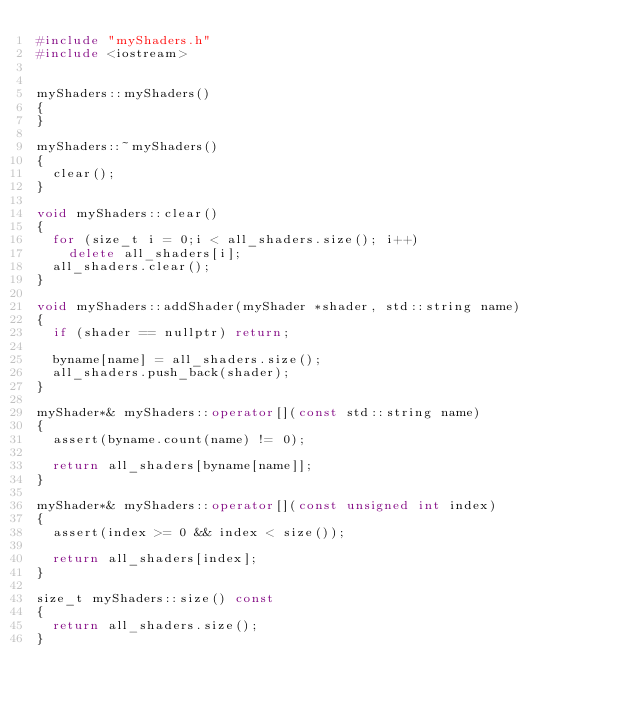<code> <loc_0><loc_0><loc_500><loc_500><_C++_>#include "myShaders.h"
#include <iostream>


myShaders::myShaders()
{
}

myShaders::~myShaders()
{
	clear();
}

void myShaders::clear()
{
	for (size_t i = 0;i < all_shaders.size(); i++)
		delete all_shaders[i];
	all_shaders.clear();
}

void myShaders::addShader(myShader *shader, std::string name)
{
	if (shader == nullptr) return;

	byname[name] = all_shaders.size();
	all_shaders.push_back(shader);
}

myShader*& myShaders::operator[](const std::string name)
{
	assert(byname.count(name) != 0);
	
	return all_shaders[byname[name]];
}

myShader*& myShaders::operator[](const unsigned int index)
{
	assert(index >= 0 && index < size());

	return all_shaders[index];
}

size_t myShaders::size() const
{
	return all_shaders.size();
}
</code> 